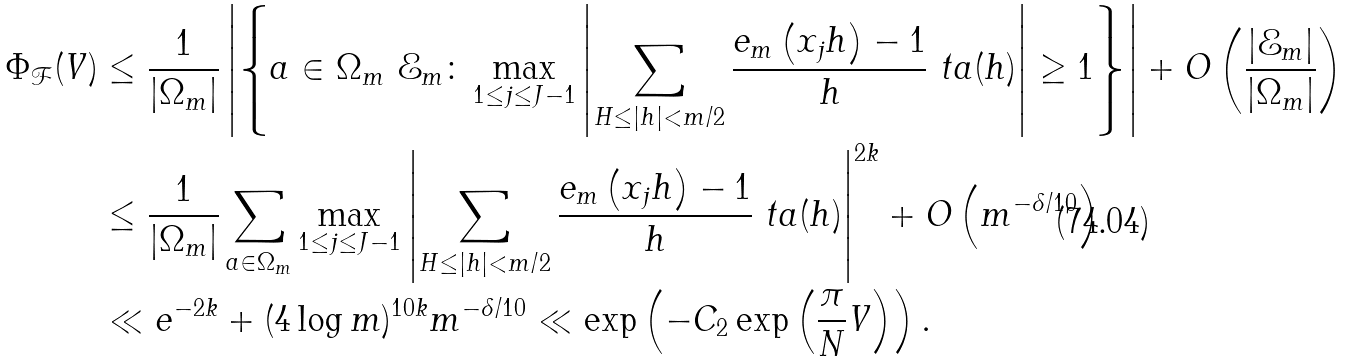<formula> <loc_0><loc_0><loc_500><loc_500>\Phi _ { \mathcal { F } } ( V ) & \leq \frac { 1 } { | \Omega _ { m } | } \left | \left \{ a \in \Omega _ { m } \ \mathcal { E } _ { m } \colon \max _ { 1 \leq j \leq J - 1 } \left | \sum _ { H \leq | h | < m / 2 } \frac { e _ { m } \left ( x _ { j } h \right ) - 1 } { h } \ t a ( h ) \right | \geq 1 \right \} \right | + O \left ( \frac { | \mathcal { E } _ { m } | } { | \Omega _ { m } | } \right ) \\ & \leq \frac { 1 } { | \Omega _ { m } | } \sum _ { a \in \Omega _ { m } } \max _ { 1 \leq j \leq J - 1 } \left | \sum _ { H \leq | h | < m / 2 } \frac { e _ { m } \left ( x _ { j } h \right ) - 1 } { h } \ t a ( h ) \right | ^ { 2 k } + O \left ( m ^ { - \delta / 1 0 } \right ) \\ & \ll e ^ { - 2 k } + ( 4 \log m ) ^ { 1 0 k } m ^ { - \delta / 1 0 } \ll \exp \left ( - C _ { 2 } \exp \left ( \frac { \pi } { N } V \right ) \right ) .</formula> 